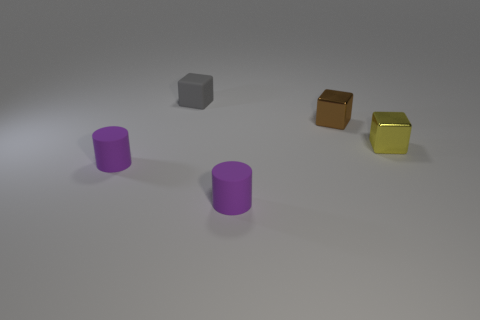What number of other objects are the same color as the rubber cube?
Offer a very short reply. 0. What number of objects are either tiny yellow cylinders or yellow shiny objects?
Keep it short and to the point. 1. What number of objects are big red metal cylinders or metallic blocks behind the yellow shiny object?
Ensure brevity in your answer.  1. Does the yellow thing have the same material as the small brown thing?
Your answer should be compact. Yes. What number of other objects are there of the same material as the brown cube?
Offer a very short reply. 1. Are there more big cubes than tiny gray matte objects?
Offer a terse response. No. There is a brown thing behind the tiny yellow block; does it have the same shape as the tiny yellow thing?
Your answer should be very brief. Yes. Is the number of brown metal things less than the number of big green blocks?
Ensure brevity in your answer.  No. What material is the yellow cube that is the same size as the brown block?
Ensure brevity in your answer.  Metal. Does the small matte cube have the same color as the tiny matte cylinder that is to the left of the tiny gray block?
Ensure brevity in your answer.  No. 